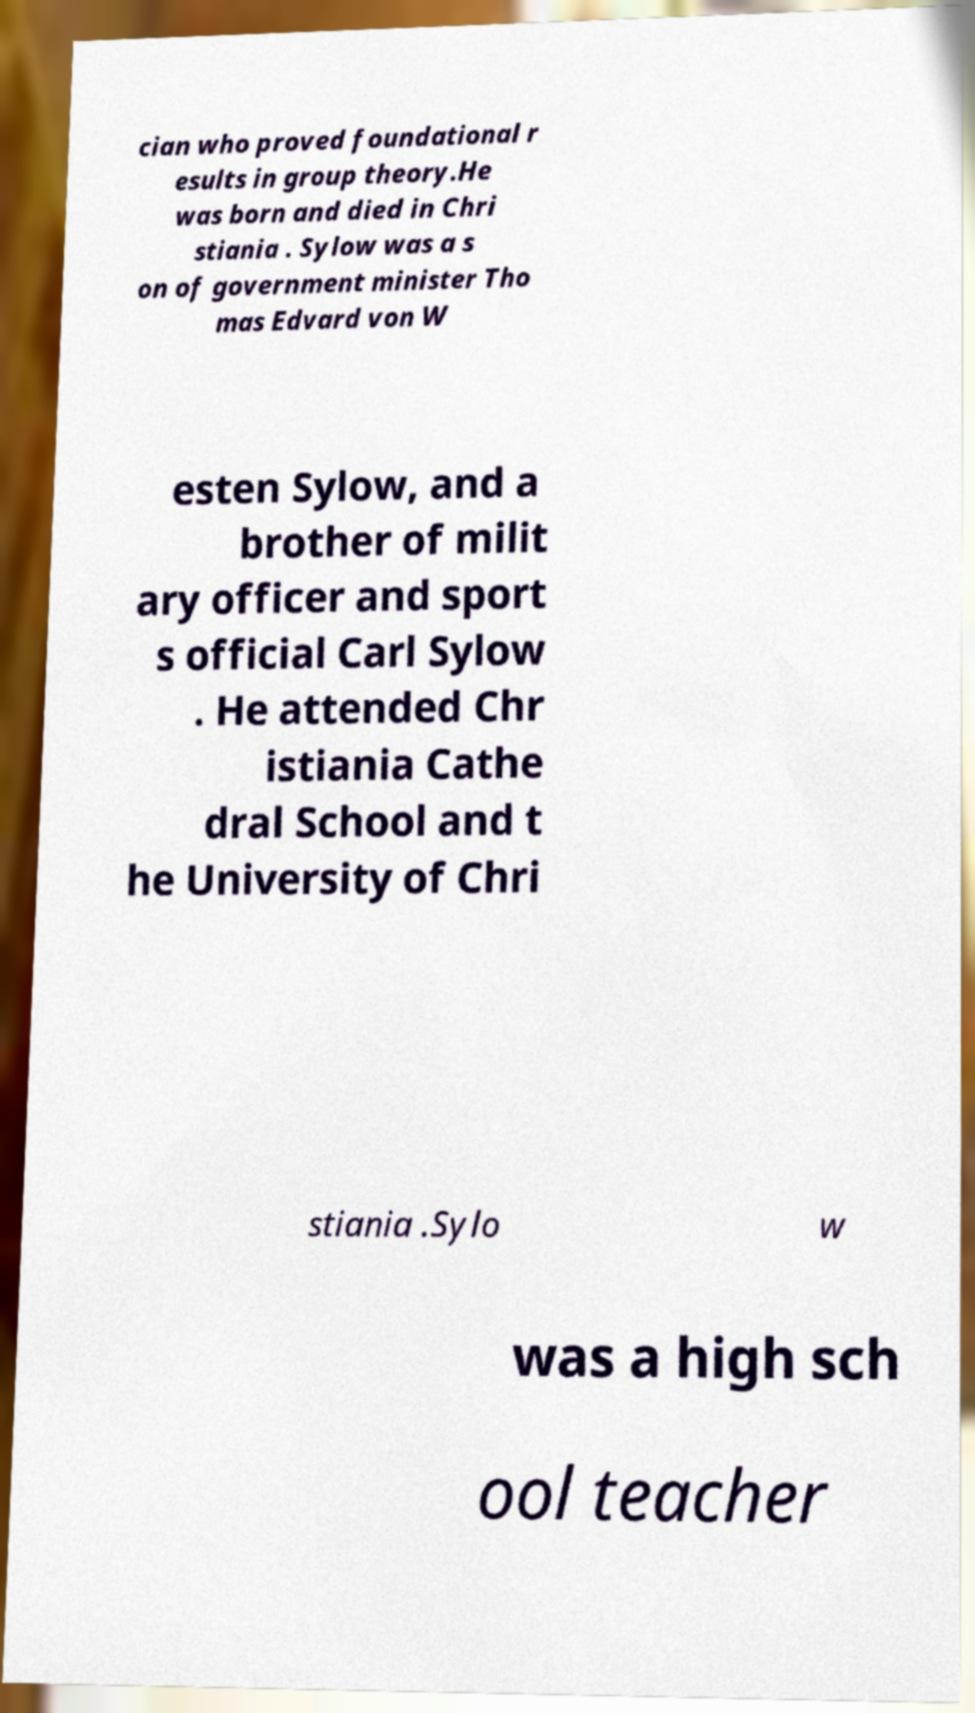I need the written content from this picture converted into text. Can you do that? cian who proved foundational r esults in group theory.He was born and died in Chri stiania . Sylow was a s on of government minister Tho mas Edvard von W esten Sylow, and a brother of milit ary officer and sport s official Carl Sylow . He attended Chr istiania Cathe dral School and t he University of Chri stiania .Sylo w was a high sch ool teacher 